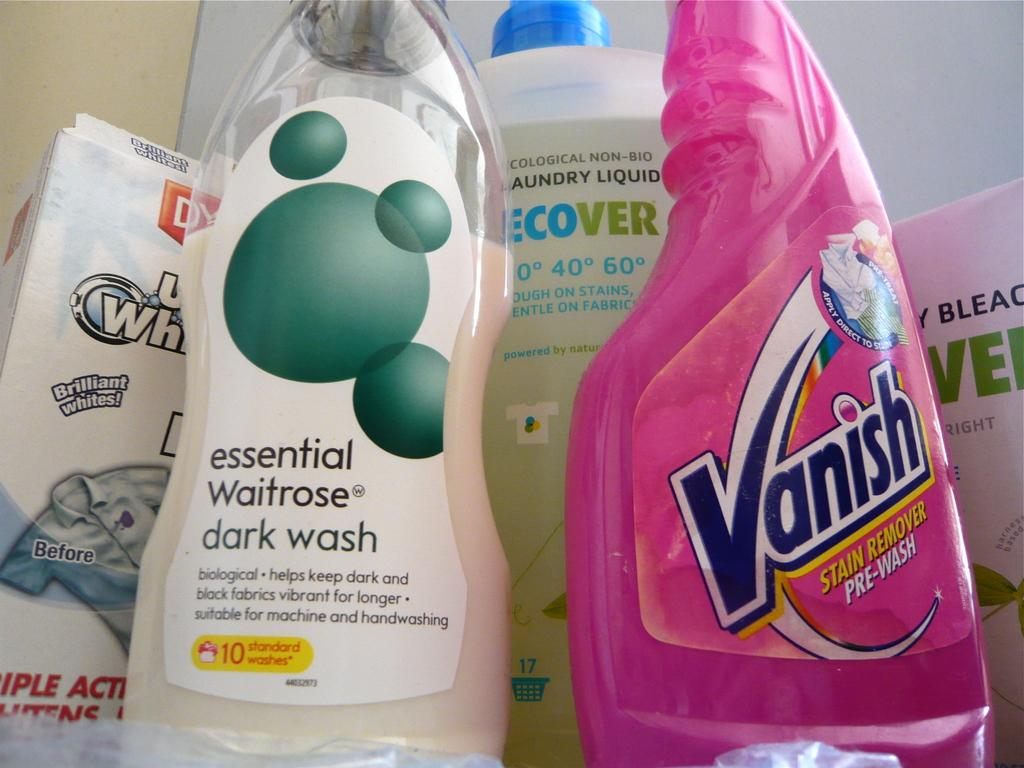How many bottles are present in the room? There are three bottles in the room. What else can be found in the room besides the bottles? There is a poster in the room. Are the bottles decorated or labeled in any way? Yes, the bottles have stickers on them. Are there any cobwebs visible in the room? There is no mention of cobwebs in the provided facts, so we cannot determine if any are present in the image. 